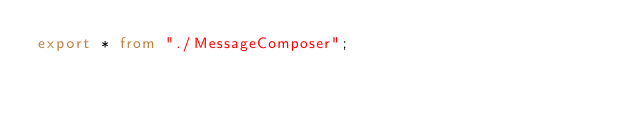Convert code to text. <code><loc_0><loc_0><loc_500><loc_500><_TypeScript_>export * from "./MessageComposer";
</code> 